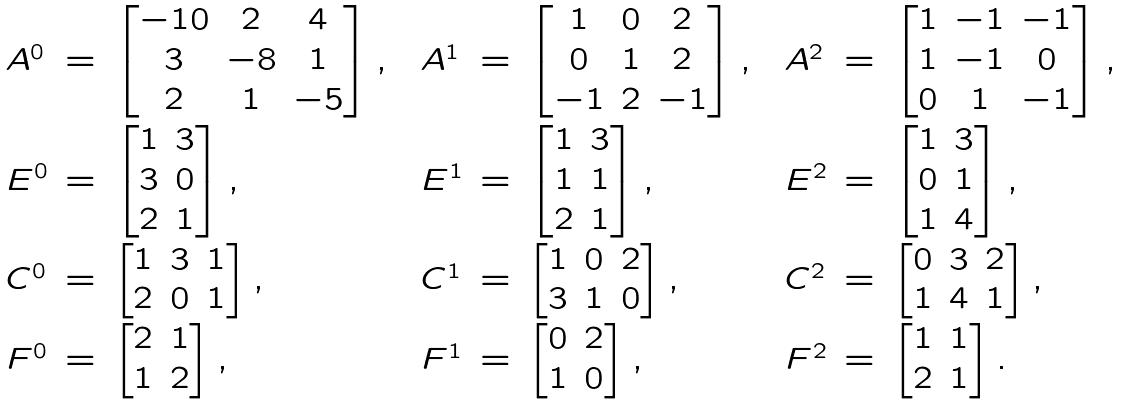<formula> <loc_0><loc_0><loc_500><loc_500>\begin{array} { l c l c l c l c l c l } A ^ { 0 } & = & \begin{bmatrix} - 1 0 & 2 & 4 \\ 3 & - 8 & 1 \\ 2 & 1 & - 5 \end{bmatrix} , & & A ^ { 1 } & = & \begin{bmatrix} 1 & 0 & 2 \\ 0 & 1 & 2 \\ - 1 & 2 & - 1 \end{bmatrix} , & & A ^ { 2 } & = & \begin{bmatrix} 1 & - 1 & - 1 \\ 1 & - 1 & 0 \\ 0 & 1 & - 1 \end{bmatrix} , \\ E ^ { 0 } & = & \begin{bmatrix} 1 & 3 \\ 3 & 0 \\ 2 & 1 \end{bmatrix} , & & E ^ { 1 } & = & \begin{bmatrix} 1 & 3 \\ 1 & 1 \\ 2 & 1 \end{bmatrix} , & & E ^ { 2 } & = & \begin{bmatrix} 1 & 3 \\ 0 & 1 \\ 1 & 4 \end{bmatrix} , \\ C ^ { 0 } & = & \begin{bmatrix} 1 & 3 & 1 \\ 2 & 0 & 1 \end{bmatrix} , & & C ^ { 1 } & = & \begin{bmatrix} 1 & 0 & 2 \\ 3 & 1 & 0 \end{bmatrix} , & & C ^ { 2 } & = & \begin{bmatrix} 0 & 3 & 2 \\ 1 & 4 & 1 \end{bmatrix} , \\ F ^ { 0 } & = & \begin{bmatrix} 2 & 1 \\ 1 & 2 \end{bmatrix} , & & F ^ { 1 } & = & \begin{bmatrix} 0 & 2 \\ 1 & 0 \end{bmatrix} , & & F ^ { 2 } & = & \begin{bmatrix} 1 & 1 \\ 2 & 1 \end{bmatrix} . \end{array}</formula> 